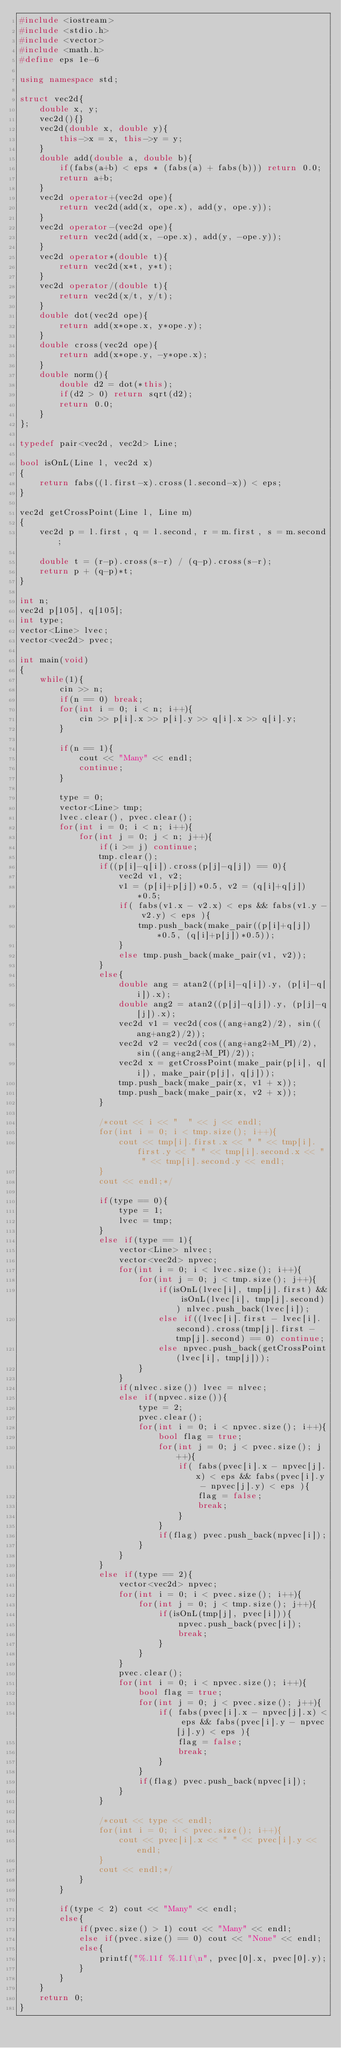Convert code to text. <code><loc_0><loc_0><loc_500><loc_500><_C++_>#include <iostream>
#include <stdio.h>
#include <vector>
#include <math.h>
#define eps 1e-6

using namespace std;

struct vec2d{
	double x, y;
	vec2d(){}
	vec2d(double x, double y){
		this->x = x, this->y = y;
	}
	double add(double a, double b){
		if(fabs(a+b) < eps * (fabs(a) + fabs(b))) return 0.0;
		return a+b;
	}
	vec2d operator+(vec2d ope){
		return vec2d(add(x, ope.x), add(y, ope.y));
	}
	vec2d operator-(vec2d ope){
		return vec2d(add(x, -ope.x), add(y, -ope.y));
	}
	vec2d operator*(double t){
		return vec2d(x*t, y*t);
	}
	vec2d operator/(double t){
		return vec2d(x/t, y/t);
	}
	double dot(vec2d ope){
		return add(x*ope.x, y*ope.y);
	}
	double cross(vec2d ope){
		return add(x*ope.y, -y*ope.x);
	}
	double norm(){
		double d2 = dot(*this);
		if(d2 > 0) return sqrt(d2);
		return 0.0;
	}
};

typedef pair<vec2d, vec2d> Line;

bool isOnL(Line l, vec2d x)
{
	return fabs((l.first-x).cross(l.second-x)) < eps;
}

vec2d getCrossPoint(Line l, Line m)
{
	vec2d p = l.first, q = l.second, r = m.first, s = m.second;
	
	double t = (r-p).cross(s-r) / (q-p).cross(s-r);
	return p + (q-p)*t;
}

int n;
vec2d p[105], q[105];
int type;
vector<Line> lvec;
vector<vec2d> pvec;

int main(void)
{
	while(1){
		cin >> n;
		if(n == 0) break;
		for(int i = 0; i < n; i++){
			cin >> p[i].x >> p[i].y >> q[i].x >> q[i].y;
		}
		
		if(n == 1){
			cout << "Many" << endl;
			continue;
		}
		
		type = 0;
		vector<Line> tmp;
		lvec.clear(), pvec.clear();
		for(int i = 0; i < n; i++){
			for(int j = 0; j < n; j++){
				if(i >= j) continue;
				tmp.clear();
				if((p[i]-q[i]).cross(p[j]-q[j]) == 0){
					vec2d v1, v2;
					v1 = (p[i]+p[j])*0.5, v2 = (q[i]+q[j])*0.5;
					if( fabs(v1.x - v2.x) < eps && fabs(v1.y - v2.y) < eps ){
						tmp.push_back(make_pair((p[i]+q[j])*0.5, (q[i]+p[j])*0.5));
					}
					else tmp.push_back(make_pair(v1, v2));
				}
				else{
					double ang = atan2((p[i]-q[i]).y, (p[i]-q[i]).x);
					double ang2 = atan2((p[j]-q[j]).y, (p[j]-q[j]).x);
					vec2d v1 = vec2d(cos((ang+ang2)/2), sin((ang+ang2)/2));
					vec2d v2 = vec2d(cos((ang+ang2+M_PI)/2), sin((ang+ang2+M_PI)/2));
					vec2d x = getCrossPoint(make_pair(p[i], q[i]), make_pair(p[j], q[j]));
					tmp.push_back(make_pair(x, v1 + x));
					tmp.push_back(make_pair(x, v2 + x));
				}
				
				/*cout << i << "  " << j << endl;
				for(int i = 0; i < tmp.size(); i++){
					cout << tmp[i].first.x << " " << tmp[i].first.y << " " << tmp[i].second.x << " " << tmp[i].second.y << endl;
				}
				cout << endl;*/
				
				if(type == 0){
					type = 1;
					lvec = tmp;
				}
				else if(type == 1){
					vector<Line> nlvec;
					vector<vec2d> npvec;
					for(int i = 0; i < lvec.size(); i++){
						for(int j = 0; j < tmp.size(); j++){
							if(isOnL(lvec[i], tmp[j].first) && isOnL(lvec[i], tmp[j].second)) nlvec.push_back(lvec[i]);
							else if((lvec[i].first - lvec[i].second).cross(tmp[j].first - tmp[j].second) == 0) continue;
							else npvec.push_back(getCrossPoint(lvec[i], tmp[j]));
						}
					}
					if(nlvec.size()) lvec = nlvec;
					else if(npvec.size()){
						type = 2;
						pvec.clear();
						for(int i = 0; i < npvec.size(); i++){
							bool flag = true;
							for(int j = 0; j < pvec.size(); j++){
								if( fabs(pvec[i].x - npvec[j].x) < eps && fabs(pvec[i].y - npvec[j].y) < eps ){
									flag = false;
									break;
								}
							}
							if(flag) pvec.push_back(npvec[i]);
						}
					}
				}
				else if(type == 2){
					vector<vec2d> npvec;
					for(int i = 0; i < pvec.size(); i++){
						for(int j = 0; j < tmp.size(); j++){
							if(isOnL(tmp[j], pvec[i])){
								npvec.push_back(pvec[i]);
								break;
							}
						}
					}
					pvec.clear();
					for(int i = 0; i < npvec.size(); i++){
						bool flag = true;
						for(int j = 0; j < pvec.size(); j++){
							if( fabs(pvec[i].x - npvec[j].x) < eps && fabs(pvec[i].y - npvec[j].y) < eps ){
								flag = false;
								break;
							}
						}
						if(flag) pvec.push_back(npvec[i]);
					}
				}
				
				/*cout << type << endl;
				for(int i = 0; i < pvec.size(); i++){
					cout << pvec[i].x << " " << pvec[i].y << endl;
				}
				cout << endl;*/
			}
		}
		
		if(type < 2) cout << "Many" << endl;
		else{
			if(pvec.size() > 1) cout << "Many" << endl;
			else if(pvec.size() == 0) cout << "None" << endl;
			else{
				printf("%.11f %.11f\n", pvec[0].x, pvec[0].y);
			}
		}
	}
	return 0;
}

</code> 